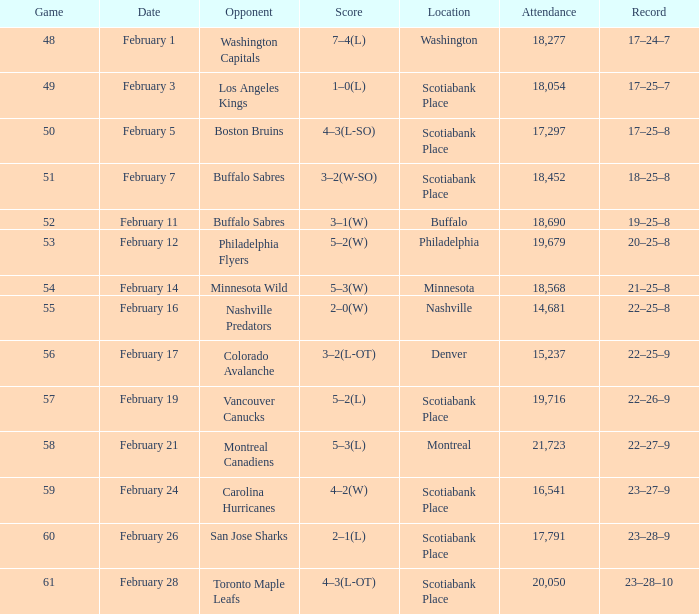What quantity of game has an audience of 18,690? 52.0. 